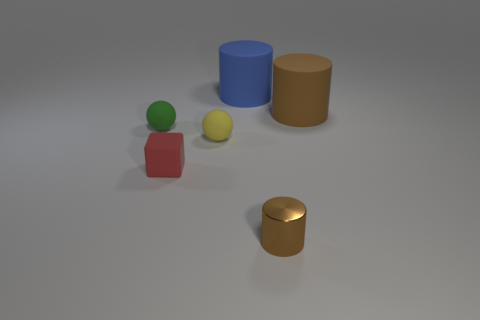How many objects are there, and can you describe their shapes and colors? In the image, there are five distinct objects. Starting from the left, there's a small green ball, a red cube, a yellow sphere, a blue cylinder, and a brown cylinder. Farther to the right, there's a separate golden cylinder positioned by itself. 